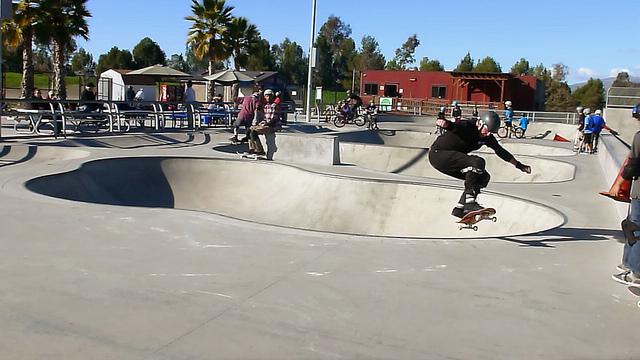Is the skateboarder wearing a helmet for safety?
Answer briefly. Yes. How many windows are on the red building in the background?
Give a very brief answer. 3. How many people are in mid-air in the photo?
Short answer required. 1. Is this a skateboarding park?
Be succinct. Yes. 